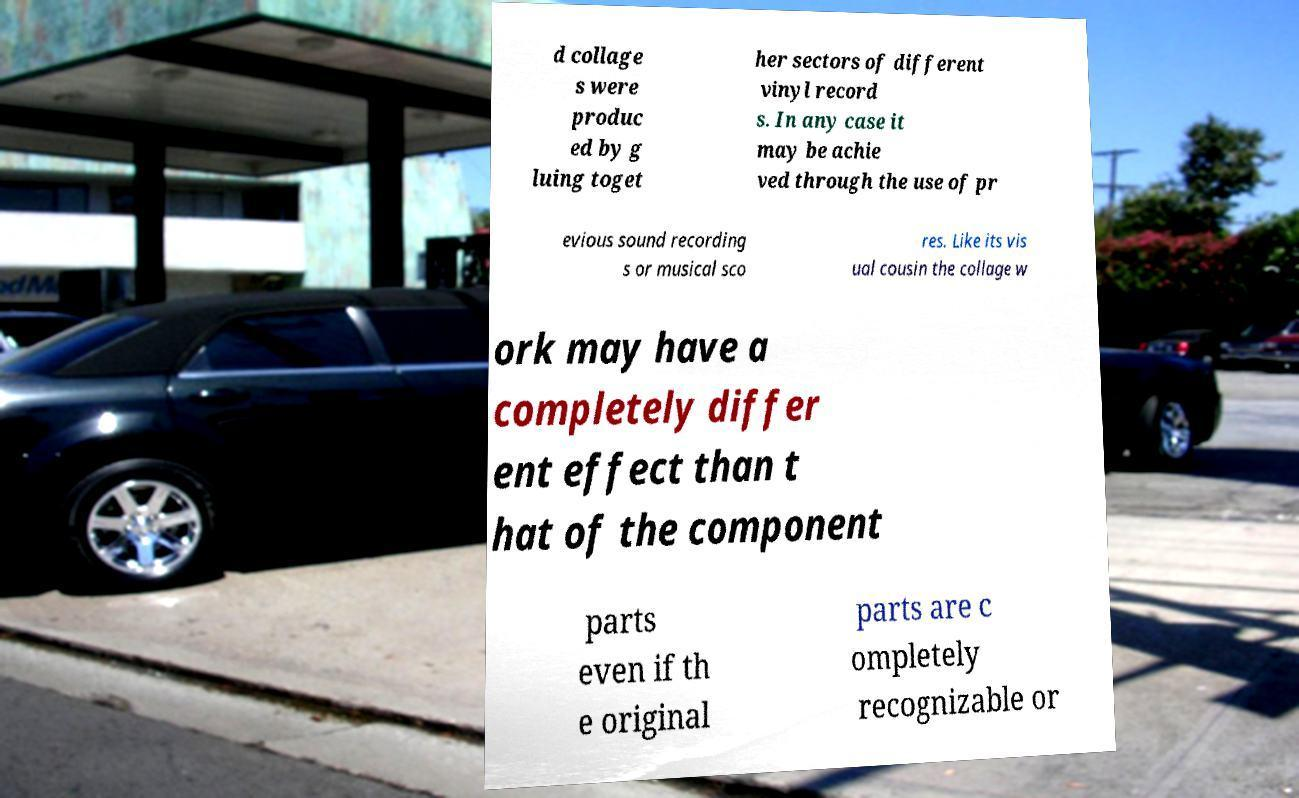Could you extract and type out the text from this image? d collage s were produc ed by g luing toget her sectors of different vinyl record s. In any case it may be achie ved through the use of pr evious sound recording s or musical sco res. Like its vis ual cousin the collage w ork may have a completely differ ent effect than t hat of the component parts even if th e original parts are c ompletely recognizable or 